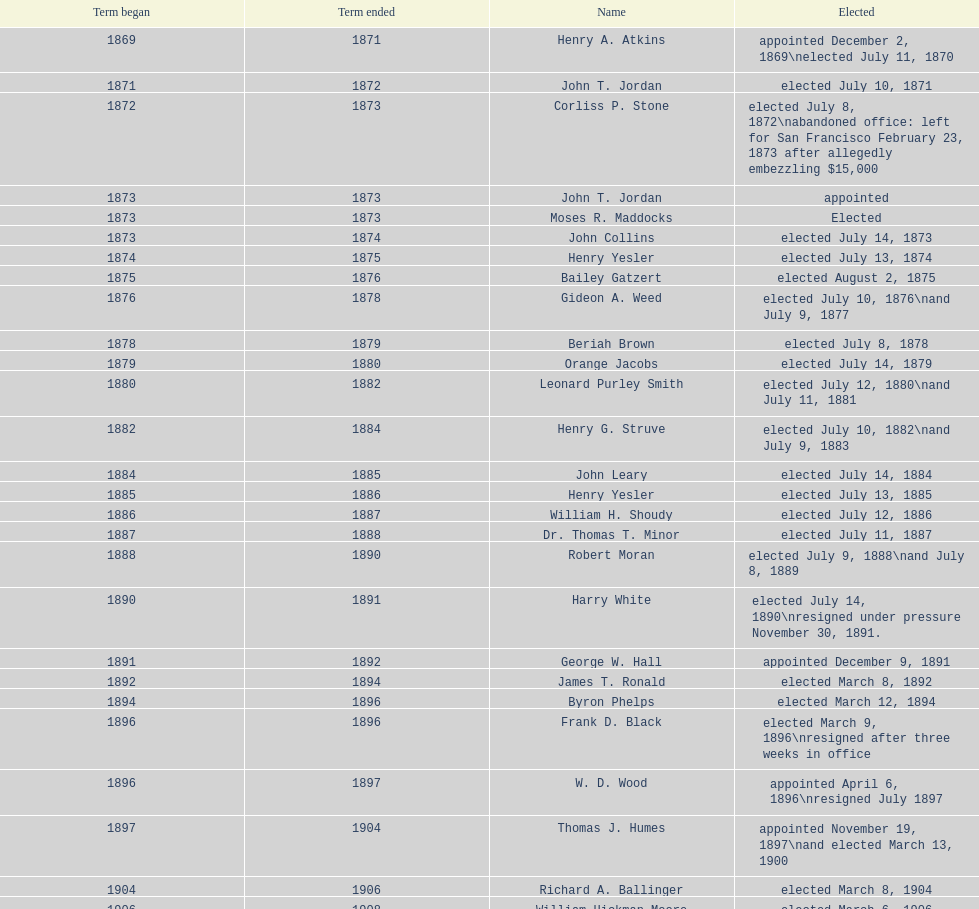How many days did robert moran serve? 365. 